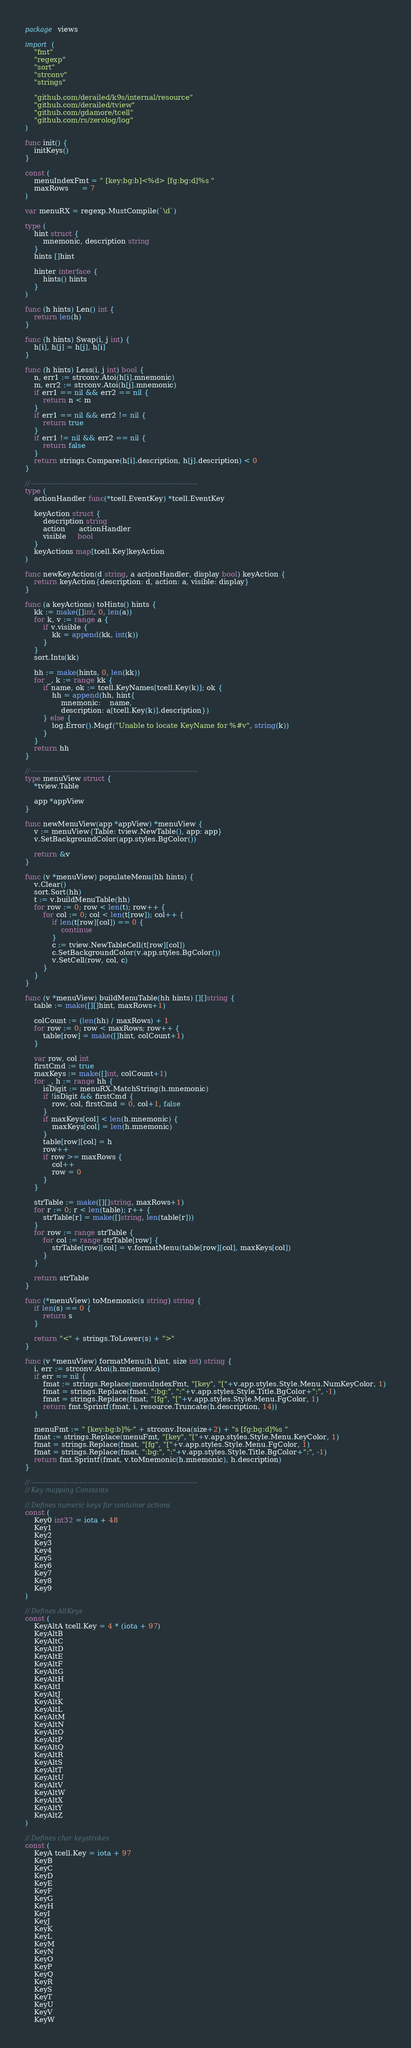Convert code to text. <code><loc_0><loc_0><loc_500><loc_500><_Go_>package views

import (
	"fmt"
	"regexp"
	"sort"
	"strconv"
	"strings"

	"github.com/derailed/k9s/internal/resource"
	"github.com/derailed/tview"
	"github.com/gdamore/tcell"
	"github.com/rs/zerolog/log"
)

func init() {
	initKeys()
}

const (
	menuIndexFmt = " [key:bg:b]<%d> [fg:bg:d]%s "
	maxRows      = 7
)

var menuRX = regexp.MustCompile(`\d`)

type (
	hint struct {
		mnemonic, description string
	}
	hints []hint

	hinter interface {
		hints() hints
	}
)

func (h hints) Len() int {
	return len(h)
}

func (h hints) Swap(i, j int) {
	h[i], h[j] = h[j], h[i]
}

func (h hints) Less(i, j int) bool {
	n, err1 := strconv.Atoi(h[i].mnemonic)
	m, err2 := strconv.Atoi(h[j].mnemonic)
	if err1 == nil && err2 == nil {
		return n < m
	}
	if err1 == nil && err2 != nil {
		return true
	}
	if err1 != nil && err2 == nil {
		return false
	}
	return strings.Compare(h[i].description, h[j].description) < 0
}

// -----------------------------------------------------------------------------
type (
	actionHandler func(*tcell.EventKey) *tcell.EventKey

	keyAction struct {
		description string
		action      actionHandler
		visible     bool
	}
	keyActions map[tcell.Key]keyAction
)

func newKeyAction(d string, a actionHandler, display bool) keyAction {
	return keyAction{description: d, action: a, visible: display}
}

func (a keyActions) toHints() hints {
	kk := make([]int, 0, len(a))
	for k, v := range a {
		if v.visible {
			kk = append(kk, int(k))
		}
	}
	sort.Ints(kk)

	hh := make(hints, 0, len(kk))
	for _, k := range kk {
		if name, ok := tcell.KeyNames[tcell.Key(k)]; ok {
			hh = append(hh, hint{
				mnemonic:    name,
				description: a[tcell.Key(k)].description})
		} else {
			log.Error().Msgf("Unable to locate KeyName for %#v", string(k))
		}
	}
	return hh
}

// -----------------------------------------------------------------------------
type menuView struct {
	*tview.Table

	app *appView
}

func newMenuView(app *appView) *menuView {
	v := menuView{Table: tview.NewTable(), app: app}
	v.SetBackgroundColor(app.styles.BgColor())

	return &v
}

func (v *menuView) populateMenu(hh hints) {
	v.Clear()
	sort.Sort(hh)
	t := v.buildMenuTable(hh)
	for row := 0; row < len(t); row++ {
		for col := 0; col < len(t[row]); col++ {
			if len(t[row][col]) == 0 {
				continue
			}
			c := tview.NewTableCell(t[row][col])
			c.SetBackgroundColor(v.app.styles.BgColor())
			v.SetCell(row, col, c)
		}
	}
}

func (v *menuView) buildMenuTable(hh hints) [][]string {
	table := make([][]hint, maxRows+1)

	colCount := (len(hh) / maxRows) + 1
	for row := 0; row < maxRows; row++ {
		table[row] = make([]hint, colCount+1)
	}

	var row, col int
	firstCmd := true
	maxKeys := make([]int, colCount+1)
	for _, h := range hh {
		isDigit := menuRX.MatchString(h.mnemonic)
		if !isDigit && firstCmd {
			row, col, firstCmd = 0, col+1, false
		}
		if maxKeys[col] < len(h.mnemonic) {
			maxKeys[col] = len(h.mnemonic)
		}
		table[row][col] = h
		row++
		if row >= maxRows {
			col++
			row = 0
		}
	}

	strTable := make([][]string, maxRows+1)
	for r := 0; r < len(table); r++ {
		strTable[r] = make([]string, len(table[r]))
	}
	for row := range strTable {
		for col := range strTable[row] {
			strTable[row][col] = v.formatMenu(table[row][col], maxKeys[col])
		}
	}

	return strTable
}

func (*menuView) toMnemonic(s string) string {
	if len(s) == 0 {
		return s
	}

	return "<" + strings.ToLower(s) + ">"
}

func (v *menuView) formatMenu(h hint, size int) string {
	i, err := strconv.Atoi(h.mnemonic)
	if err == nil {
		fmat := strings.Replace(menuIndexFmt, "[key", "["+v.app.styles.Style.Menu.NumKeyColor, 1)
		fmat = strings.Replace(fmat, ":bg:", ":"+v.app.styles.Style.Title.BgColor+":", -1)
		fmat = strings.Replace(fmat, "[fg", "["+v.app.styles.Style.Menu.FgColor, 1)
		return fmt.Sprintf(fmat, i, resource.Truncate(h.description, 14))
	}

	menuFmt := " [key:bg:b]%-" + strconv.Itoa(size+2) + "s [fg:bg:d]%s "
	fmat := strings.Replace(menuFmt, "[key", "["+v.app.styles.Style.Menu.KeyColor, 1)
	fmat = strings.Replace(fmat, "[fg", "["+v.app.styles.Style.Menu.FgColor, 1)
	fmat = strings.Replace(fmat, ":bg:", ":"+v.app.styles.Style.Title.BgColor+":", -1)
	return fmt.Sprintf(fmat, v.toMnemonic(h.mnemonic), h.description)
}

// -----------------------------------------------------------------------------
// Key mapping Constants

// Defines numeric keys for container actions
const (
	Key0 int32 = iota + 48
	Key1
	Key2
	Key3
	Key4
	Key5
	Key6
	Key7
	Key8
	Key9
)

// Defines AltKeys
const (
	KeyAltA tcell.Key = 4 * (iota + 97)
	KeyAltB
	KeyAltC
	KeyAltD
	KeyAltE
	KeyAltF
	KeyAltG
	KeyAltH
	KeyAltI
	KeyAltJ
	KeyAltK
	KeyAltL
	KeyAltM
	KeyAltN
	KeyAltO
	KeyAltP
	KeyAltQ
	KeyAltR
	KeyAltS
	KeyAltT
	KeyAltU
	KeyAltV
	KeyAltW
	KeyAltX
	KeyAltY
	KeyAltZ
)

// Defines char keystrokes
const (
	KeyA tcell.Key = iota + 97
	KeyB
	KeyC
	KeyD
	KeyE
	KeyF
	KeyG
	KeyH
	KeyI
	KeyJ
	KeyK
	KeyL
	KeyM
	KeyN
	KeyO
	KeyP
	KeyQ
	KeyR
	KeyS
	KeyT
	KeyU
	KeyV
	KeyW</code> 